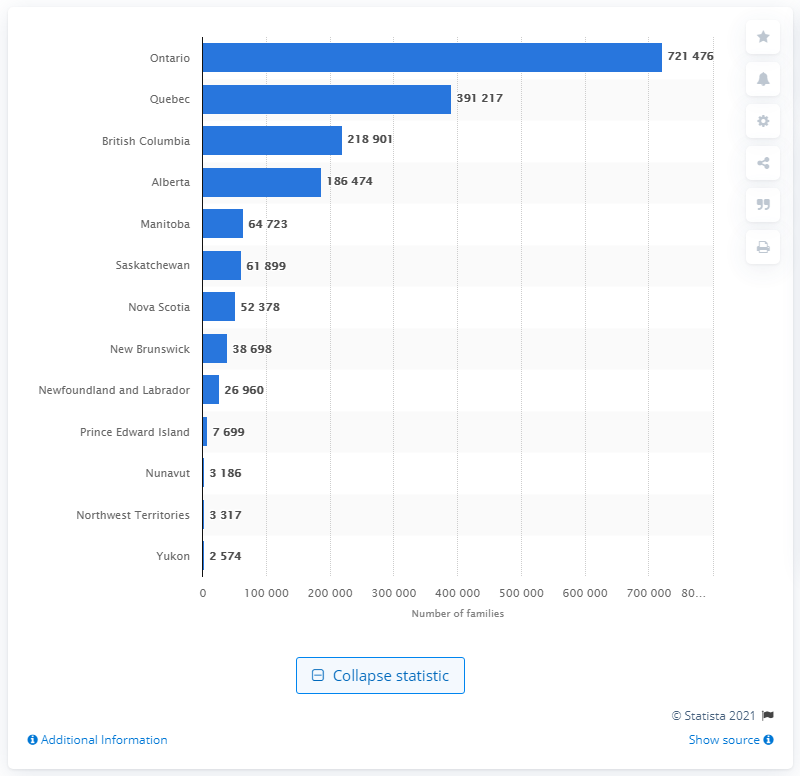Mention a couple of crucial points in this snapshot. According to data from 2020, Ontario had the highest number of lone parent families among all provinces in Canada. 